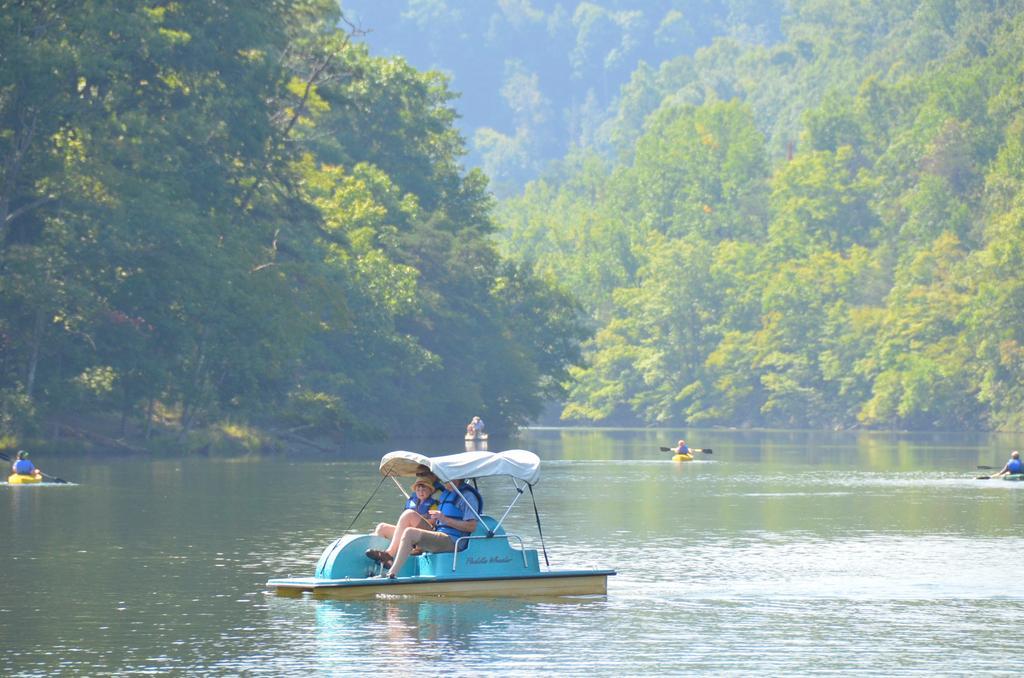How would you summarize this image in a sentence or two? In this picture I can see few people are sitting in a boat, in the background few persons are rowing the boats on the water. At the top there are trees. 